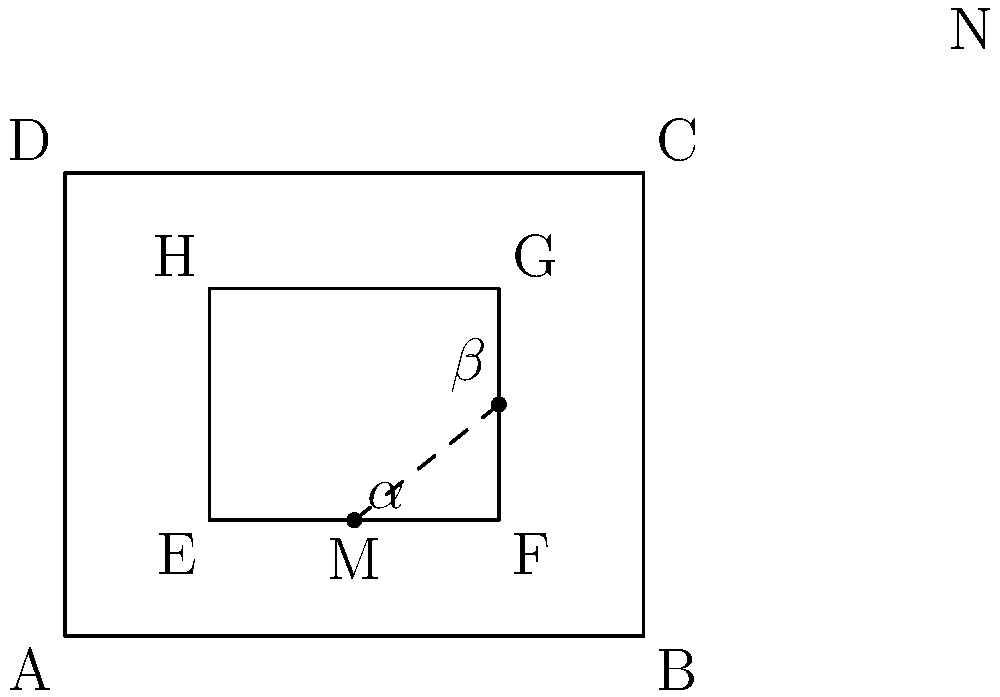In the design of a concert hall, the rectangular stage EFGH is positioned within the larger rectangular hall ABCD. For optimal acoustics, the ratio of the stage width to the hall width is 1:2, and the ratio of the stage depth to the hall depth is 1:4. If the angle $\alpha$ formed by the line MN and the stage floor is 30°, what is the measure of angle $\beta$? Let's approach this step-by-step:

1) First, we need to understand the proportions given:
   - Stage width : Hall width = 1 : 2
   - Stage depth : Hall depth = 1 : 4

2) Let's denote:
   EF = stage width
   EH = stage depth
   AB = hall width
   AD = hall depth

3) From the proportions:
   EF = 1/2 * AB
   EH = 1/4 * AD

4) In the right triangle MNF:
   tan($\alpha$) = NF / MF
   
5) We know $\alpha$ = 30°, so:
   tan(30°) = NF / MF
   1/√3 = NF / MF

6) Now, MF = 1/4 * EF (as M is the midpoint of EF)
   And NF = 1/2 * FG = 1/2 * EH (as N is the midpoint of FG)

7) Substituting these into the tan equation:
   1/√3 = (1/2 * EH) / (1/4 * EF)
   1/√3 = 2 * EH / EF

8) We know that EH : AD = 1 : 4 and EF : AB = 1 : 2
   So, EH : EF = (1/4 * AD) : (1/2 * AB) = 1 : 2

9) Substituting this ratio into our equation:
   1/√3 = 2 * (1/2)
   1/√3 = 1

10) This is indeed true, confirming our calculations.

11) Now, in the right triangle MNF:
    tan($\beta$) = MF / NF = (1/4 * EF) / (1/2 * EH) = 1/2

12) Therefore, $\beta$ = arctan(1/2) ≈ 26.57°
Answer: $\beta \approx 26.57°$ 